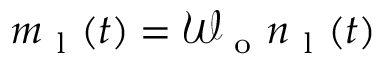<formula> <loc_0><loc_0><loc_500><loc_500>m _ { l } ( t ) = \mathcal { W } _ { o } n _ { l } ( t )</formula> 